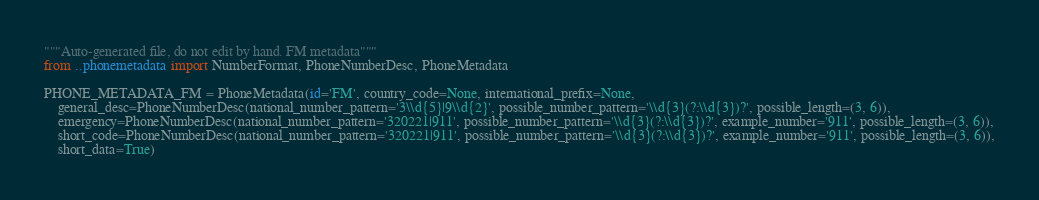Convert code to text. <code><loc_0><loc_0><loc_500><loc_500><_Python_>"""Auto-generated file, do not edit by hand. FM metadata"""
from ..phonemetadata import NumberFormat, PhoneNumberDesc, PhoneMetadata

PHONE_METADATA_FM = PhoneMetadata(id='FM', country_code=None, international_prefix=None,
    general_desc=PhoneNumberDesc(national_number_pattern='3\\d{5}|9\\d{2}', possible_number_pattern='\\d{3}(?:\\d{3})?', possible_length=(3, 6)),
    emergency=PhoneNumberDesc(national_number_pattern='320221|911', possible_number_pattern='\\d{3}(?:\\d{3})?', example_number='911', possible_length=(3, 6)),
    short_code=PhoneNumberDesc(national_number_pattern='320221|911', possible_number_pattern='\\d{3}(?:\\d{3})?', example_number='911', possible_length=(3, 6)),
    short_data=True)
</code> 